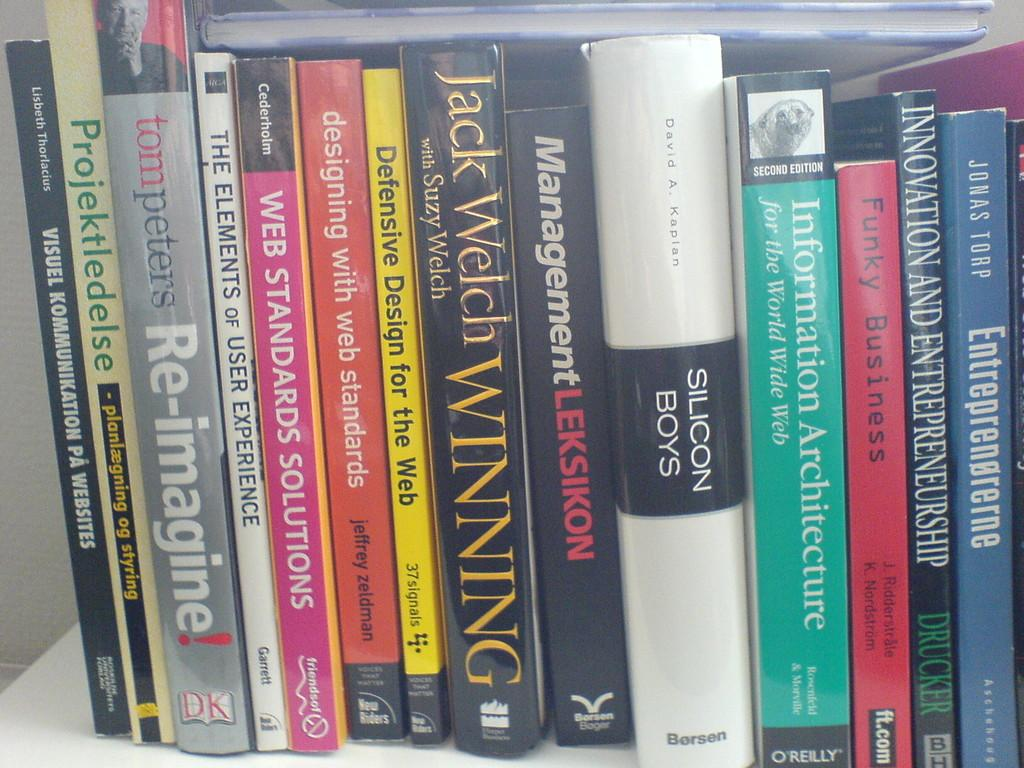<image>
Offer a succinct explanation of the picture presented. A book about Silicon Boys sits on a shelf among other books 